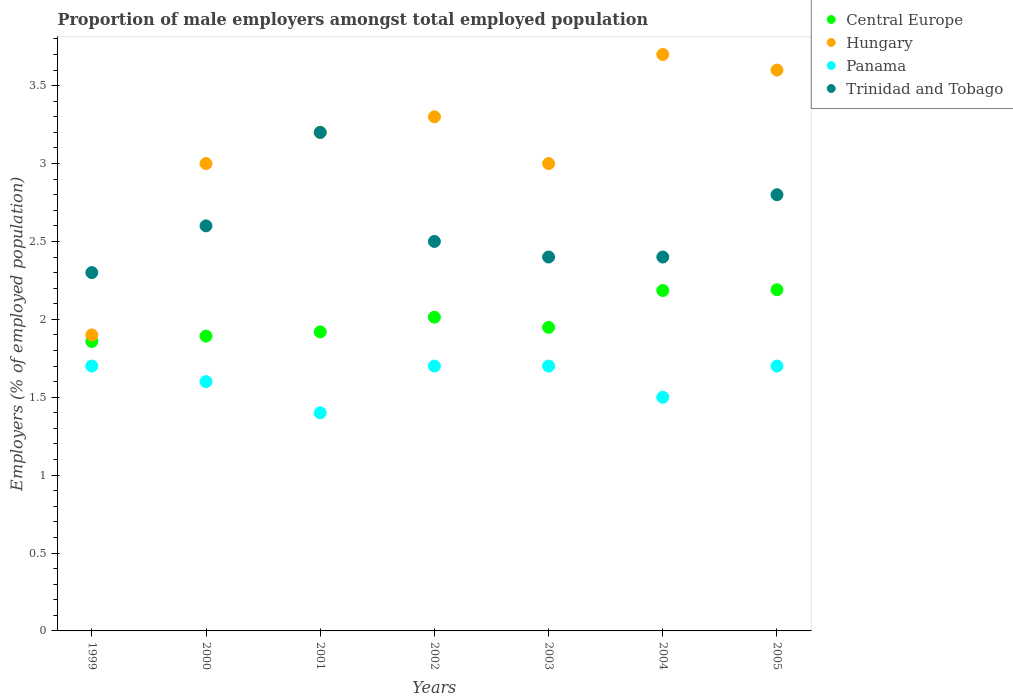Is the number of dotlines equal to the number of legend labels?
Keep it short and to the point. Yes. What is the proportion of male employers in Hungary in 2002?
Your answer should be compact. 3.3. Across all years, what is the maximum proportion of male employers in Hungary?
Offer a very short reply. 3.7. Across all years, what is the minimum proportion of male employers in Central Europe?
Provide a succinct answer. 1.86. In which year was the proportion of male employers in Hungary minimum?
Offer a terse response. 1999. What is the total proportion of male employers in Trinidad and Tobago in the graph?
Offer a terse response. 18.2. What is the difference between the proportion of male employers in Panama in 2001 and that in 2002?
Ensure brevity in your answer.  -0.3. What is the difference between the proportion of male employers in Panama in 2002 and the proportion of male employers in Hungary in 1999?
Provide a short and direct response. -0.2. What is the average proportion of male employers in Trinidad and Tobago per year?
Keep it short and to the point. 2.6. In the year 2005, what is the difference between the proportion of male employers in Central Europe and proportion of male employers in Panama?
Offer a very short reply. 0.49. In how many years, is the proportion of male employers in Hungary greater than 1.4 %?
Your answer should be compact. 7. Is the proportion of male employers in Hungary in 2002 less than that in 2003?
Your answer should be very brief. No. What is the difference between the highest and the second highest proportion of male employers in Hungary?
Provide a succinct answer. 0.1. What is the difference between the highest and the lowest proportion of male employers in Panama?
Provide a short and direct response. 0.3. Is the sum of the proportion of male employers in Hungary in 2000 and 2001 greater than the maximum proportion of male employers in Central Europe across all years?
Offer a terse response. Yes. Is it the case that in every year, the sum of the proportion of male employers in Central Europe and proportion of male employers in Hungary  is greater than the sum of proportion of male employers in Panama and proportion of male employers in Trinidad and Tobago?
Offer a very short reply. Yes. How many years are there in the graph?
Provide a succinct answer. 7. Does the graph contain grids?
Offer a very short reply. No. What is the title of the graph?
Offer a terse response. Proportion of male employers amongst total employed population. What is the label or title of the X-axis?
Your answer should be compact. Years. What is the label or title of the Y-axis?
Your response must be concise. Employers (% of employed population). What is the Employers (% of employed population) of Central Europe in 1999?
Your response must be concise. 1.86. What is the Employers (% of employed population) in Hungary in 1999?
Keep it short and to the point. 1.9. What is the Employers (% of employed population) of Panama in 1999?
Provide a short and direct response. 1.7. What is the Employers (% of employed population) of Trinidad and Tobago in 1999?
Give a very brief answer. 2.3. What is the Employers (% of employed population) in Central Europe in 2000?
Make the answer very short. 1.89. What is the Employers (% of employed population) in Panama in 2000?
Make the answer very short. 1.6. What is the Employers (% of employed population) in Trinidad and Tobago in 2000?
Provide a short and direct response. 2.6. What is the Employers (% of employed population) of Central Europe in 2001?
Ensure brevity in your answer.  1.92. What is the Employers (% of employed population) in Hungary in 2001?
Your answer should be compact. 3.2. What is the Employers (% of employed population) in Panama in 2001?
Your answer should be very brief. 1.4. What is the Employers (% of employed population) in Trinidad and Tobago in 2001?
Your answer should be compact. 3.2. What is the Employers (% of employed population) in Central Europe in 2002?
Offer a very short reply. 2.01. What is the Employers (% of employed population) in Hungary in 2002?
Give a very brief answer. 3.3. What is the Employers (% of employed population) of Panama in 2002?
Your response must be concise. 1.7. What is the Employers (% of employed population) of Trinidad and Tobago in 2002?
Give a very brief answer. 2.5. What is the Employers (% of employed population) in Central Europe in 2003?
Your response must be concise. 1.95. What is the Employers (% of employed population) in Hungary in 2003?
Your answer should be compact. 3. What is the Employers (% of employed population) of Panama in 2003?
Offer a terse response. 1.7. What is the Employers (% of employed population) of Trinidad and Tobago in 2003?
Offer a terse response. 2.4. What is the Employers (% of employed population) in Central Europe in 2004?
Make the answer very short. 2.19. What is the Employers (% of employed population) in Hungary in 2004?
Give a very brief answer. 3.7. What is the Employers (% of employed population) in Trinidad and Tobago in 2004?
Your answer should be compact. 2.4. What is the Employers (% of employed population) of Central Europe in 2005?
Your answer should be compact. 2.19. What is the Employers (% of employed population) of Hungary in 2005?
Keep it short and to the point. 3.6. What is the Employers (% of employed population) of Panama in 2005?
Provide a succinct answer. 1.7. What is the Employers (% of employed population) of Trinidad and Tobago in 2005?
Make the answer very short. 2.8. Across all years, what is the maximum Employers (% of employed population) of Central Europe?
Your answer should be compact. 2.19. Across all years, what is the maximum Employers (% of employed population) of Hungary?
Provide a short and direct response. 3.7. Across all years, what is the maximum Employers (% of employed population) of Panama?
Give a very brief answer. 1.7. Across all years, what is the maximum Employers (% of employed population) of Trinidad and Tobago?
Keep it short and to the point. 3.2. Across all years, what is the minimum Employers (% of employed population) of Central Europe?
Your answer should be compact. 1.86. Across all years, what is the minimum Employers (% of employed population) in Hungary?
Offer a terse response. 1.9. Across all years, what is the minimum Employers (% of employed population) in Panama?
Provide a succinct answer. 1.4. Across all years, what is the minimum Employers (% of employed population) of Trinidad and Tobago?
Offer a very short reply. 2.3. What is the total Employers (% of employed population) in Central Europe in the graph?
Make the answer very short. 14.01. What is the total Employers (% of employed population) of Hungary in the graph?
Offer a terse response. 21.7. What is the total Employers (% of employed population) of Panama in the graph?
Ensure brevity in your answer.  11.3. What is the total Employers (% of employed population) of Trinidad and Tobago in the graph?
Offer a terse response. 18.2. What is the difference between the Employers (% of employed population) in Central Europe in 1999 and that in 2000?
Your answer should be very brief. -0.03. What is the difference between the Employers (% of employed population) in Panama in 1999 and that in 2000?
Your response must be concise. 0.1. What is the difference between the Employers (% of employed population) in Central Europe in 1999 and that in 2001?
Provide a succinct answer. -0.06. What is the difference between the Employers (% of employed population) of Hungary in 1999 and that in 2001?
Offer a very short reply. -1.3. What is the difference between the Employers (% of employed population) in Panama in 1999 and that in 2001?
Make the answer very short. 0.3. What is the difference between the Employers (% of employed population) of Central Europe in 1999 and that in 2002?
Make the answer very short. -0.16. What is the difference between the Employers (% of employed population) in Hungary in 1999 and that in 2002?
Your answer should be very brief. -1.4. What is the difference between the Employers (% of employed population) of Trinidad and Tobago in 1999 and that in 2002?
Keep it short and to the point. -0.2. What is the difference between the Employers (% of employed population) in Central Europe in 1999 and that in 2003?
Offer a very short reply. -0.09. What is the difference between the Employers (% of employed population) in Panama in 1999 and that in 2003?
Ensure brevity in your answer.  0. What is the difference between the Employers (% of employed population) in Trinidad and Tobago in 1999 and that in 2003?
Your response must be concise. -0.1. What is the difference between the Employers (% of employed population) in Central Europe in 1999 and that in 2004?
Your answer should be very brief. -0.33. What is the difference between the Employers (% of employed population) of Hungary in 1999 and that in 2004?
Make the answer very short. -1.8. What is the difference between the Employers (% of employed population) in Panama in 1999 and that in 2004?
Keep it short and to the point. 0.2. What is the difference between the Employers (% of employed population) in Central Europe in 1999 and that in 2005?
Your answer should be compact. -0.33. What is the difference between the Employers (% of employed population) of Hungary in 1999 and that in 2005?
Your answer should be compact. -1.7. What is the difference between the Employers (% of employed population) in Panama in 1999 and that in 2005?
Make the answer very short. 0. What is the difference between the Employers (% of employed population) of Trinidad and Tobago in 1999 and that in 2005?
Make the answer very short. -0.5. What is the difference between the Employers (% of employed population) in Central Europe in 2000 and that in 2001?
Your response must be concise. -0.03. What is the difference between the Employers (% of employed population) in Trinidad and Tobago in 2000 and that in 2001?
Provide a succinct answer. -0.6. What is the difference between the Employers (% of employed population) of Central Europe in 2000 and that in 2002?
Your answer should be compact. -0.12. What is the difference between the Employers (% of employed population) in Hungary in 2000 and that in 2002?
Give a very brief answer. -0.3. What is the difference between the Employers (% of employed population) in Panama in 2000 and that in 2002?
Make the answer very short. -0.1. What is the difference between the Employers (% of employed population) in Central Europe in 2000 and that in 2003?
Provide a short and direct response. -0.06. What is the difference between the Employers (% of employed population) of Panama in 2000 and that in 2003?
Keep it short and to the point. -0.1. What is the difference between the Employers (% of employed population) in Central Europe in 2000 and that in 2004?
Provide a short and direct response. -0.29. What is the difference between the Employers (% of employed population) in Panama in 2000 and that in 2004?
Provide a succinct answer. 0.1. What is the difference between the Employers (% of employed population) in Central Europe in 2000 and that in 2005?
Your answer should be very brief. -0.3. What is the difference between the Employers (% of employed population) in Hungary in 2000 and that in 2005?
Offer a very short reply. -0.6. What is the difference between the Employers (% of employed population) in Central Europe in 2001 and that in 2002?
Offer a very short reply. -0.09. What is the difference between the Employers (% of employed population) in Hungary in 2001 and that in 2002?
Provide a short and direct response. -0.1. What is the difference between the Employers (% of employed population) of Panama in 2001 and that in 2002?
Keep it short and to the point. -0.3. What is the difference between the Employers (% of employed population) of Trinidad and Tobago in 2001 and that in 2002?
Your answer should be very brief. 0.7. What is the difference between the Employers (% of employed population) of Central Europe in 2001 and that in 2003?
Ensure brevity in your answer.  -0.03. What is the difference between the Employers (% of employed population) in Hungary in 2001 and that in 2003?
Offer a terse response. 0.2. What is the difference between the Employers (% of employed population) in Panama in 2001 and that in 2003?
Make the answer very short. -0.3. What is the difference between the Employers (% of employed population) of Trinidad and Tobago in 2001 and that in 2003?
Your answer should be compact. 0.8. What is the difference between the Employers (% of employed population) of Central Europe in 2001 and that in 2004?
Keep it short and to the point. -0.27. What is the difference between the Employers (% of employed population) in Hungary in 2001 and that in 2004?
Your response must be concise. -0.5. What is the difference between the Employers (% of employed population) of Trinidad and Tobago in 2001 and that in 2004?
Keep it short and to the point. 0.8. What is the difference between the Employers (% of employed population) in Central Europe in 2001 and that in 2005?
Give a very brief answer. -0.27. What is the difference between the Employers (% of employed population) in Panama in 2001 and that in 2005?
Ensure brevity in your answer.  -0.3. What is the difference between the Employers (% of employed population) of Central Europe in 2002 and that in 2003?
Provide a short and direct response. 0.07. What is the difference between the Employers (% of employed population) of Hungary in 2002 and that in 2003?
Your answer should be very brief. 0.3. What is the difference between the Employers (% of employed population) in Panama in 2002 and that in 2003?
Offer a very short reply. 0. What is the difference between the Employers (% of employed population) in Central Europe in 2002 and that in 2004?
Provide a succinct answer. -0.17. What is the difference between the Employers (% of employed population) in Hungary in 2002 and that in 2004?
Your response must be concise. -0.4. What is the difference between the Employers (% of employed population) of Central Europe in 2002 and that in 2005?
Provide a short and direct response. -0.18. What is the difference between the Employers (% of employed population) of Trinidad and Tobago in 2002 and that in 2005?
Your answer should be compact. -0.3. What is the difference between the Employers (% of employed population) in Central Europe in 2003 and that in 2004?
Make the answer very short. -0.24. What is the difference between the Employers (% of employed population) in Hungary in 2003 and that in 2004?
Offer a terse response. -0.7. What is the difference between the Employers (% of employed population) of Panama in 2003 and that in 2004?
Offer a very short reply. 0.2. What is the difference between the Employers (% of employed population) of Trinidad and Tobago in 2003 and that in 2004?
Your answer should be very brief. 0. What is the difference between the Employers (% of employed population) in Central Europe in 2003 and that in 2005?
Provide a succinct answer. -0.24. What is the difference between the Employers (% of employed population) of Hungary in 2003 and that in 2005?
Make the answer very short. -0.6. What is the difference between the Employers (% of employed population) of Central Europe in 2004 and that in 2005?
Offer a terse response. -0.01. What is the difference between the Employers (% of employed population) of Central Europe in 1999 and the Employers (% of employed population) of Hungary in 2000?
Keep it short and to the point. -1.14. What is the difference between the Employers (% of employed population) of Central Europe in 1999 and the Employers (% of employed population) of Panama in 2000?
Keep it short and to the point. 0.26. What is the difference between the Employers (% of employed population) in Central Europe in 1999 and the Employers (% of employed population) in Trinidad and Tobago in 2000?
Make the answer very short. -0.74. What is the difference between the Employers (% of employed population) in Central Europe in 1999 and the Employers (% of employed population) in Hungary in 2001?
Ensure brevity in your answer.  -1.34. What is the difference between the Employers (% of employed population) of Central Europe in 1999 and the Employers (% of employed population) of Panama in 2001?
Your response must be concise. 0.46. What is the difference between the Employers (% of employed population) in Central Europe in 1999 and the Employers (% of employed population) in Trinidad and Tobago in 2001?
Offer a very short reply. -1.34. What is the difference between the Employers (% of employed population) in Hungary in 1999 and the Employers (% of employed population) in Trinidad and Tobago in 2001?
Keep it short and to the point. -1.3. What is the difference between the Employers (% of employed population) in Central Europe in 1999 and the Employers (% of employed population) in Hungary in 2002?
Your answer should be compact. -1.44. What is the difference between the Employers (% of employed population) in Central Europe in 1999 and the Employers (% of employed population) in Panama in 2002?
Provide a short and direct response. 0.16. What is the difference between the Employers (% of employed population) in Central Europe in 1999 and the Employers (% of employed population) in Trinidad and Tobago in 2002?
Make the answer very short. -0.64. What is the difference between the Employers (% of employed population) of Hungary in 1999 and the Employers (% of employed population) of Panama in 2002?
Make the answer very short. 0.2. What is the difference between the Employers (% of employed population) of Hungary in 1999 and the Employers (% of employed population) of Trinidad and Tobago in 2002?
Offer a terse response. -0.6. What is the difference between the Employers (% of employed population) of Panama in 1999 and the Employers (% of employed population) of Trinidad and Tobago in 2002?
Your response must be concise. -0.8. What is the difference between the Employers (% of employed population) of Central Europe in 1999 and the Employers (% of employed population) of Hungary in 2003?
Your response must be concise. -1.14. What is the difference between the Employers (% of employed population) of Central Europe in 1999 and the Employers (% of employed population) of Panama in 2003?
Keep it short and to the point. 0.16. What is the difference between the Employers (% of employed population) in Central Europe in 1999 and the Employers (% of employed population) in Trinidad and Tobago in 2003?
Your response must be concise. -0.54. What is the difference between the Employers (% of employed population) in Hungary in 1999 and the Employers (% of employed population) in Panama in 2003?
Offer a terse response. 0.2. What is the difference between the Employers (% of employed population) in Hungary in 1999 and the Employers (% of employed population) in Trinidad and Tobago in 2003?
Provide a succinct answer. -0.5. What is the difference between the Employers (% of employed population) of Panama in 1999 and the Employers (% of employed population) of Trinidad and Tobago in 2003?
Keep it short and to the point. -0.7. What is the difference between the Employers (% of employed population) in Central Europe in 1999 and the Employers (% of employed population) in Hungary in 2004?
Keep it short and to the point. -1.84. What is the difference between the Employers (% of employed population) in Central Europe in 1999 and the Employers (% of employed population) in Panama in 2004?
Ensure brevity in your answer.  0.36. What is the difference between the Employers (% of employed population) of Central Europe in 1999 and the Employers (% of employed population) of Trinidad and Tobago in 2004?
Keep it short and to the point. -0.54. What is the difference between the Employers (% of employed population) in Central Europe in 1999 and the Employers (% of employed population) in Hungary in 2005?
Provide a succinct answer. -1.74. What is the difference between the Employers (% of employed population) of Central Europe in 1999 and the Employers (% of employed population) of Panama in 2005?
Ensure brevity in your answer.  0.16. What is the difference between the Employers (% of employed population) in Central Europe in 1999 and the Employers (% of employed population) in Trinidad and Tobago in 2005?
Offer a very short reply. -0.94. What is the difference between the Employers (% of employed population) in Hungary in 1999 and the Employers (% of employed population) in Panama in 2005?
Offer a very short reply. 0.2. What is the difference between the Employers (% of employed population) of Central Europe in 2000 and the Employers (% of employed population) of Hungary in 2001?
Offer a very short reply. -1.31. What is the difference between the Employers (% of employed population) in Central Europe in 2000 and the Employers (% of employed population) in Panama in 2001?
Provide a succinct answer. 0.49. What is the difference between the Employers (% of employed population) of Central Europe in 2000 and the Employers (% of employed population) of Trinidad and Tobago in 2001?
Ensure brevity in your answer.  -1.31. What is the difference between the Employers (% of employed population) in Hungary in 2000 and the Employers (% of employed population) in Trinidad and Tobago in 2001?
Give a very brief answer. -0.2. What is the difference between the Employers (% of employed population) of Central Europe in 2000 and the Employers (% of employed population) of Hungary in 2002?
Your response must be concise. -1.41. What is the difference between the Employers (% of employed population) in Central Europe in 2000 and the Employers (% of employed population) in Panama in 2002?
Provide a succinct answer. 0.19. What is the difference between the Employers (% of employed population) of Central Europe in 2000 and the Employers (% of employed population) of Trinidad and Tobago in 2002?
Your response must be concise. -0.61. What is the difference between the Employers (% of employed population) in Hungary in 2000 and the Employers (% of employed population) in Panama in 2002?
Offer a terse response. 1.3. What is the difference between the Employers (% of employed population) in Panama in 2000 and the Employers (% of employed population) in Trinidad and Tobago in 2002?
Your answer should be very brief. -0.9. What is the difference between the Employers (% of employed population) in Central Europe in 2000 and the Employers (% of employed population) in Hungary in 2003?
Your answer should be very brief. -1.11. What is the difference between the Employers (% of employed population) of Central Europe in 2000 and the Employers (% of employed population) of Panama in 2003?
Make the answer very short. 0.19. What is the difference between the Employers (% of employed population) in Central Europe in 2000 and the Employers (% of employed population) in Trinidad and Tobago in 2003?
Offer a very short reply. -0.51. What is the difference between the Employers (% of employed population) in Hungary in 2000 and the Employers (% of employed population) in Panama in 2003?
Ensure brevity in your answer.  1.3. What is the difference between the Employers (% of employed population) in Hungary in 2000 and the Employers (% of employed population) in Trinidad and Tobago in 2003?
Provide a succinct answer. 0.6. What is the difference between the Employers (% of employed population) in Central Europe in 2000 and the Employers (% of employed population) in Hungary in 2004?
Ensure brevity in your answer.  -1.81. What is the difference between the Employers (% of employed population) of Central Europe in 2000 and the Employers (% of employed population) of Panama in 2004?
Your answer should be very brief. 0.39. What is the difference between the Employers (% of employed population) of Central Europe in 2000 and the Employers (% of employed population) of Trinidad and Tobago in 2004?
Your answer should be very brief. -0.51. What is the difference between the Employers (% of employed population) in Hungary in 2000 and the Employers (% of employed population) in Panama in 2004?
Keep it short and to the point. 1.5. What is the difference between the Employers (% of employed population) in Hungary in 2000 and the Employers (% of employed population) in Trinidad and Tobago in 2004?
Give a very brief answer. 0.6. What is the difference between the Employers (% of employed population) in Central Europe in 2000 and the Employers (% of employed population) in Hungary in 2005?
Your answer should be very brief. -1.71. What is the difference between the Employers (% of employed population) of Central Europe in 2000 and the Employers (% of employed population) of Panama in 2005?
Offer a terse response. 0.19. What is the difference between the Employers (% of employed population) of Central Europe in 2000 and the Employers (% of employed population) of Trinidad and Tobago in 2005?
Make the answer very short. -0.91. What is the difference between the Employers (% of employed population) in Hungary in 2000 and the Employers (% of employed population) in Trinidad and Tobago in 2005?
Provide a short and direct response. 0.2. What is the difference between the Employers (% of employed population) in Central Europe in 2001 and the Employers (% of employed population) in Hungary in 2002?
Make the answer very short. -1.38. What is the difference between the Employers (% of employed population) of Central Europe in 2001 and the Employers (% of employed population) of Panama in 2002?
Offer a very short reply. 0.22. What is the difference between the Employers (% of employed population) of Central Europe in 2001 and the Employers (% of employed population) of Trinidad and Tobago in 2002?
Ensure brevity in your answer.  -0.58. What is the difference between the Employers (% of employed population) of Hungary in 2001 and the Employers (% of employed population) of Trinidad and Tobago in 2002?
Ensure brevity in your answer.  0.7. What is the difference between the Employers (% of employed population) in Panama in 2001 and the Employers (% of employed population) in Trinidad and Tobago in 2002?
Provide a short and direct response. -1.1. What is the difference between the Employers (% of employed population) of Central Europe in 2001 and the Employers (% of employed population) of Hungary in 2003?
Offer a very short reply. -1.08. What is the difference between the Employers (% of employed population) of Central Europe in 2001 and the Employers (% of employed population) of Panama in 2003?
Make the answer very short. 0.22. What is the difference between the Employers (% of employed population) of Central Europe in 2001 and the Employers (% of employed population) of Trinidad and Tobago in 2003?
Your response must be concise. -0.48. What is the difference between the Employers (% of employed population) of Central Europe in 2001 and the Employers (% of employed population) of Hungary in 2004?
Make the answer very short. -1.78. What is the difference between the Employers (% of employed population) of Central Europe in 2001 and the Employers (% of employed population) of Panama in 2004?
Keep it short and to the point. 0.42. What is the difference between the Employers (% of employed population) in Central Europe in 2001 and the Employers (% of employed population) in Trinidad and Tobago in 2004?
Keep it short and to the point. -0.48. What is the difference between the Employers (% of employed population) in Hungary in 2001 and the Employers (% of employed population) in Trinidad and Tobago in 2004?
Offer a terse response. 0.8. What is the difference between the Employers (% of employed population) in Central Europe in 2001 and the Employers (% of employed population) in Hungary in 2005?
Your response must be concise. -1.68. What is the difference between the Employers (% of employed population) in Central Europe in 2001 and the Employers (% of employed population) in Panama in 2005?
Your answer should be very brief. 0.22. What is the difference between the Employers (% of employed population) of Central Europe in 2001 and the Employers (% of employed population) of Trinidad and Tobago in 2005?
Your answer should be compact. -0.88. What is the difference between the Employers (% of employed population) of Hungary in 2001 and the Employers (% of employed population) of Panama in 2005?
Your answer should be very brief. 1.5. What is the difference between the Employers (% of employed population) of Panama in 2001 and the Employers (% of employed population) of Trinidad and Tobago in 2005?
Make the answer very short. -1.4. What is the difference between the Employers (% of employed population) in Central Europe in 2002 and the Employers (% of employed population) in Hungary in 2003?
Your answer should be compact. -0.99. What is the difference between the Employers (% of employed population) of Central Europe in 2002 and the Employers (% of employed population) of Panama in 2003?
Your answer should be compact. 0.31. What is the difference between the Employers (% of employed population) in Central Europe in 2002 and the Employers (% of employed population) in Trinidad and Tobago in 2003?
Make the answer very short. -0.39. What is the difference between the Employers (% of employed population) of Hungary in 2002 and the Employers (% of employed population) of Trinidad and Tobago in 2003?
Keep it short and to the point. 0.9. What is the difference between the Employers (% of employed population) in Panama in 2002 and the Employers (% of employed population) in Trinidad and Tobago in 2003?
Ensure brevity in your answer.  -0.7. What is the difference between the Employers (% of employed population) in Central Europe in 2002 and the Employers (% of employed population) in Hungary in 2004?
Ensure brevity in your answer.  -1.69. What is the difference between the Employers (% of employed population) in Central Europe in 2002 and the Employers (% of employed population) in Panama in 2004?
Your answer should be compact. 0.51. What is the difference between the Employers (% of employed population) of Central Europe in 2002 and the Employers (% of employed population) of Trinidad and Tobago in 2004?
Provide a succinct answer. -0.39. What is the difference between the Employers (% of employed population) of Hungary in 2002 and the Employers (% of employed population) of Panama in 2004?
Make the answer very short. 1.8. What is the difference between the Employers (% of employed population) of Central Europe in 2002 and the Employers (% of employed population) of Hungary in 2005?
Offer a terse response. -1.59. What is the difference between the Employers (% of employed population) in Central Europe in 2002 and the Employers (% of employed population) in Panama in 2005?
Your response must be concise. 0.31. What is the difference between the Employers (% of employed population) in Central Europe in 2002 and the Employers (% of employed population) in Trinidad and Tobago in 2005?
Provide a succinct answer. -0.79. What is the difference between the Employers (% of employed population) in Central Europe in 2003 and the Employers (% of employed population) in Hungary in 2004?
Offer a terse response. -1.75. What is the difference between the Employers (% of employed population) in Central Europe in 2003 and the Employers (% of employed population) in Panama in 2004?
Ensure brevity in your answer.  0.45. What is the difference between the Employers (% of employed population) in Central Europe in 2003 and the Employers (% of employed population) in Trinidad and Tobago in 2004?
Your response must be concise. -0.45. What is the difference between the Employers (% of employed population) of Hungary in 2003 and the Employers (% of employed population) of Trinidad and Tobago in 2004?
Your answer should be compact. 0.6. What is the difference between the Employers (% of employed population) of Central Europe in 2003 and the Employers (% of employed population) of Hungary in 2005?
Make the answer very short. -1.65. What is the difference between the Employers (% of employed population) of Central Europe in 2003 and the Employers (% of employed population) of Panama in 2005?
Make the answer very short. 0.25. What is the difference between the Employers (% of employed population) of Central Europe in 2003 and the Employers (% of employed population) of Trinidad and Tobago in 2005?
Provide a short and direct response. -0.85. What is the difference between the Employers (% of employed population) in Central Europe in 2004 and the Employers (% of employed population) in Hungary in 2005?
Provide a succinct answer. -1.42. What is the difference between the Employers (% of employed population) in Central Europe in 2004 and the Employers (% of employed population) in Panama in 2005?
Your response must be concise. 0.48. What is the difference between the Employers (% of employed population) in Central Europe in 2004 and the Employers (% of employed population) in Trinidad and Tobago in 2005?
Your answer should be very brief. -0.61. What is the difference between the Employers (% of employed population) in Hungary in 2004 and the Employers (% of employed population) in Panama in 2005?
Your answer should be very brief. 2. What is the difference between the Employers (% of employed population) of Panama in 2004 and the Employers (% of employed population) of Trinidad and Tobago in 2005?
Your response must be concise. -1.3. What is the average Employers (% of employed population) in Central Europe per year?
Provide a short and direct response. 2. What is the average Employers (% of employed population) in Hungary per year?
Ensure brevity in your answer.  3.1. What is the average Employers (% of employed population) of Panama per year?
Ensure brevity in your answer.  1.61. What is the average Employers (% of employed population) of Trinidad and Tobago per year?
Offer a very short reply. 2.6. In the year 1999, what is the difference between the Employers (% of employed population) of Central Europe and Employers (% of employed population) of Hungary?
Your response must be concise. -0.04. In the year 1999, what is the difference between the Employers (% of employed population) in Central Europe and Employers (% of employed population) in Panama?
Provide a succinct answer. 0.16. In the year 1999, what is the difference between the Employers (% of employed population) of Central Europe and Employers (% of employed population) of Trinidad and Tobago?
Your answer should be compact. -0.44. In the year 2000, what is the difference between the Employers (% of employed population) of Central Europe and Employers (% of employed population) of Hungary?
Offer a terse response. -1.11. In the year 2000, what is the difference between the Employers (% of employed population) of Central Europe and Employers (% of employed population) of Panama?
Provide a short and direct response. 0.29. In the year 2000, what is the difference between the Employers (% of employed population) in Central Europe and Employers (% of employed population) in Trinidad and Tobago?
Offer a terse response. -0.71. In the year 2000, what is the difference between the Employers (% of employed population) of Hungary and Employers (% of employed population) of Panama?
Offer a very short reply. 1.4. In the year 2000, what is the difference between the Employers (% of employed population) of Hungary and Employers (% of employed population) of Trinidad and Tobago?
Your answer should be very brief. 0.4. In the year 2000, what is the difference between the Employers (% of employed population) of Panama and Employers (% of employed population) of Trinidad and Tobago?
Give a very brief answer. -1. In the year 2001, what is the difference between the Employers (% of employed population) in Central Europe and Employers (% of employed population) in Hungary?
Ensure brevity in your answer.  -1.28. In the year 2001, what is the difference between the Employers (% of employed population) in Central Europe and Employers (% of employed population) in Panama?
Your answer should be very brief. 0.52. In the year 2001, what is the difference between the Employers (% of employed population) in Central Europe and Employers (% of employed population) in Trinidad and Tobago?
Provide a succinct answer. -1.28. In the year 2002, what is the difference between the Employers (% of employed population) in Central Europe and Employers (% of employed population) in Hungary?
Provide a short and direct response. -1.29. In the year 2002, what is the difference between the Employers (% of employed population) of Central Europe and Employers (% of employed population) of Panama?
Give a very brief answer. 0.31. In the year 2002, what is the difference between the Employers (% of employed population) in Central Europe and Employers (% of employed population) in Trinidad and Tobago?
Keep it short and to the point. -0.49. In the year 2003, what is the difference between the Employers (% of employed population) in Central Europe and Employers (% of employed population) in Hungary?
Your response must be concise. -1.05. In the year 2003, what is the difference between the Employers (% of employed population) of Central Europe and Employers (% of employed population) of Panama?
Your answer should be compact. 0.25. In the year 2003, what is the difference between the Employers (% of employed population) of Central Europe and Employers (% of employed population) of Trinidad and Tobago?
Your answer should be very brief. -0.45. In the year 2003, what is the difference between the Employers (% of employed population) in Hungary and Employers (% of employed population) in Panama?
Offer a terse response. 1.3. In the year 2004, what is the difference between the Employers (% of employed population) of Central Europe and Employers (% of employed population) of Hungary?
Offer a very short reply. -1.51. In the year 2004, what is the difference between the Employers (% of employed population) of Central Europe and Employers (% of employed population) of Panama?
Your answer should be very brief. 0.69. In the year 2004, what is the difference between the Employers (% of employed population) of Central Europe and Employers (% of employed population) of Trinidad and Tobago?
Provide a succinct answer. -0.21. In the year 2004, what is the difference between the Employers (% of employed population) of Panama and Employers (% of employed population) of Trinidad and Tobago?
Your answer should be very brief. -0.9. In the year 2005, what is the difference between the Employers (% of employed population) in Central Europe and Employers (% of employed population) in Hungary?
Offer a very short reply. -1.41. In the year 2005, what is the difference between the Employers (% of employed population) of Central Europe and Employers (% of employed population) of Panama?
Offer a terse response. 0.49. In the year 2005, what is the difference between the Employers (% of employed population) of Central Europe and Employers (% of employed population) of Trinidad and Tobago?
Ensure brevity in your answer.  -0.61. In the year 2005, what is the difference between the Employers (% of employed population) in Hungary and Employers (% of employed population) in Panama?
Provide a short and direct response. 1.9. What is the ratio of the Employers (% of employed population) in Central Europe in 1999 to that in 2000?
Your response must be concise. 0.98. What is the ratio of the Employers (% of employed population) in Hungary in 1999 to that in 2000?
Ensure brevity in your answer.  0.63. What is the ratio of the Employers (% of employed population) of Panama in 1999 to that in 2000?
Make the answer very short. 1.06. What is the ratio of the Employers (% of employed population) in Trinidad and Tobago in 1999 to that in 2000?
Give a very brief answer. 0.88. What is the ratio of the Employers (% of employed population) of Hungary in 1999 to that in 2001?
Give a very brief answer. 0.59. What is the ratio of the Employers (% of employed population) in Panama in 1999 to that in 2001?
Offer a terse response. 1.21. What is the ratio of the Employers (% of employed population) of Trinidad and Tobago in 1999 to that in 2001?
Your answer should be very brief. 0.72. What is the ratio of the Employers (% of employed population) of Central Europe in 1999 to that in 2002?
Ensure brevity in your answer.  0.92. What is the ratio of the Employers (% of employed population) in Hungary in 1999 to that in 2002?
Offer a very short reply. 0.58. What is the ratio of the Employers (% of employed population) of Trinidad and Tobago in 1999 to that in 2002?
Offer a very short reply. 0.92. What is the ratio of the Employers (% of employed population) in Central Europe in 1999 to that in 2003?
Offer a very short reply. 0.95. What is the ratio of the Employers (% of employed population) of Hungary in 1999 to that in 2003?
Keep it short and to the point. 0.63. What is the ratio of the Employers (% of employed population) in Panama in 1999 to that in 2003?
Offer a very short reply. 1. What is the ratio of the Employers (% of employed population) in Central Europe in 1999 to that in 2004?
Your response must be concise. 0.85. What is the ratio of the Employers (% of employed population) in Hungary in 1999 to that in 2004?
Give a very brief answer. 0.51. What is the ratio of the Employers (% of employed population) of Panama in 1999 to that in 2004?
Your response must be concise. 1.13. What is the ratio of the Employers (% of employed population) in Central Europe in 1999 to that in 2005?
Offer a terse response. 0.85. What is the ratio of the Employers (% of employed population) in Hungary in 1999 to that in 2005?
Offer a terse response. 0.53. What is the ratio of the Employers (% of employed population) in Trinidad and Tobago in 1999 to that in 2005?
Provide a short and direct response. 0.82. What is the ratio of the Employers (% of employed population) of Central Europe in 2000 to that in 2001?
Your response must be concise. 0.99. What is the ratio of the Employers (% of employed population) in Trinidad and Tobago in 2000 to that in 2001?
Provide a short and direct response. 0.81. What is the ratio of the Employers (% of employed population) in Central Europe in 2000 to that in 2002?
Ensure brevity in your answer.  0.94. What is the ratio of the Employers (% of employed population) of Hungary in 2000 to that in 2002?
Make the answer very short. 0.91. What is the ratio of the Employers (% of employed population) of Trinidad and Tobago in 2000 to that in 2002?
Your response must be concise. 1.04. What is the ratio of the Employers (% of employed population) of Central Europe in 2000 to that in 2003?
Make the answer very short. 0.97. What is the ratio of the Employers (% of employed population) in Hungary in 2000 to that in 2003?
Provide a succinct answer. 1. What is the ratio of the Employers (% of employed population) in Panama in 2000 to that in 2003?
Provide a succinct answer. 0.94. What is the ratio of the Employers (% of employed population) in Trinidad and Tobago in 2000 to that in 2003?
Keep it short and to the point. 1.08. What is the ratio of the Employers (% of employed population) of Central Europe in 2000 to that in 2004?
Provide a short and direct response. 0.87. What is the ratio of the Employers (% of employed population) of Hungary in 2000 to that in 2004?
Make the answer very short. 0.81. What is the ratio of the Employers (% of employed population) of Panama in 2000 to that in 2004?
Your answer should be very brief. 1.07. What is the ratio of the Employers (% of employed population) of Central Europe in 2000 to that in 2005?
Offer a terse response. 0.86. What is the ratio of the Employers (% of employed population) of Central Europe in 2001 to that in 2002?
Make the answer very short. 0.95. What is the ratio of the Employers (% of employed population) of Hungary in 2001 to that in 2002?
Keep it short and to the point. 0.97. What is the ratio of the Employers (% of employed population) of Panama in 2001 to that in 2002?
Offer a very short reply. 0.82. What is the ratio of the Employers (% of employed population) in Trinidad and Tobago in 2001 to that in 2002?
Your response must be concise. 1.28. What is the ratio of the Employers (% of employed population) of Central Europe in 2001 to that in 2003?
Your response must be concise. 0.99. What is the ratio of the Employers (% of employed population) in Hungary in 2001 to that in 2003?
Ensure brevity in your answer.  1.07. What is the ratio of the Employers (% of employed population) in Panama in 2001 to that in 2003?
Provide a succinct answer. 0.82. What is the ratio of the Employers (% of employed population) in Trinidad and Tobago in 2001 to that in 2003?
Provide a succinct answer. 1.33. What is the ratio of the Employers (% of employed population) in Central Europe in 2001 to that in 2004?
Give a very brief answer. 0.88. What is the ratio of the Employers (% of employed population) in Hungary in 2001 to that in 2004?
Offer a terse response. 0.86. What is the ratio of the Employers (% of employed population) in Panama in 2001 to that in 2004?
Keep it short and to the point. 0.93. What is the ratio of the Employers (% of employed population) of Central Europe in 2001 to that in 2005?
Offer a terse response. 0.88. What is the ratio of the Employers (% of employed population) in Panama in 2001 to that in 2005?
Keep it short and to the point. 0.82. What is the ratio of the Employers (% of employed population) in Central Europe in 2002 to that in 2003?
Provide a short and direct response. 1.03. What is the ratio of the Employers (% of employed population) of Hungary in 2002 to that in 2003?
Provide a short and direct response. 1.1. What is the ratio of the Employers (% of employed population) of Trinidad and Tobago in 2002 to that in 2003?
Give a very brief answer. 1.04. What is the ratio of the Employers (% of employed population) in Central Europe in 2002 to that in 2004?
Your response must be concise. 0.92. What is the ratio of the Employers (% of employed population) of Hungary in 2002 to that in 2004?
Your response must be concise. 0.89. What is the ratio of the Employers (% of employed population) of Panama in 2002 to that in 2004?
Keep it short and to the point. 1.13. What is the ratio of the Employers (% of employed population) in Trinidad and Tobago in 2002 to that in 2004?
Offer a terse response. 1.04. What is the ratio of the Employers (% of employed population) of Central Europe in 2002 to that in 2005?
Offer a very short reply. 0.92. What is the ratio of the Employers (% of employed population) in Hungary in 2002 to that in 2005?
Your response must be concise. 0.92. What is the ratio of the Employers (% of employed population) in Trinidad and Tobago in 2002 to that in 2005?
Your answer should be compact. 0.89. What is the ratio of the Employers (% of employed population) of Central Europe in 2003 to that in 2004?
Provide a short and direct response. 0.89. What is the ratio of the Employers (% of employed population) in Hungary in 2003 to that in 2004?
Make the answer very short. 0.81. What is the ratio of the Employers (% of employed population) of Panama in 2003 to that in 2004?
Give a very brief answer. 1.13. What is the ratio of the Employers (% of employed population) in Trinidad and Tobago in 2003 to that in 2004?
Give a very brief answer. 1. What is the ratio of the Employers (% of employed population) of Central Europe in 2003 to that in 2005?
Your response must be concise. 0.89. What is the ratio of the Employers (% of employed population) in Hungary in 2003 to that in 2005?
Ensure brevity in your answer.  0.83. What is the ratio of the Employers (% of employed population) in Panama in 2003 to that in 2005?
Your answer should be very brief. 1. What is the ratio of the Employers (% of employed population) in Trinidad and Tobago in 2003 to that in 2005?
Give a very brief answer. 0.86. What is the ratio of the Employers (% of employed population) in Central Europe in 2004 to that in 2005?
Provide a short and direct response. 1. What is the ratio of the Employers (% of employed population) in Hungary in 2004 to that in 2005?
Provide a short and direct response. 1.03. What is the ratio of the Employers (% of employed population) in Panama in 2004 to that in 2005?
Offer a terse response. 0.88. What is the ratio of the Employers (% of employed population) in Trinidad and Tobago in 2004 to that in 2005?
Ensure brevity in your answer.  0.86. What is the difference between the highest and the second highest Employers (% of employed population) of Central Europe?
Give a very brief answer. 0.01. What is the difference between the highest and the second highest Employers (% of employed population) of Hungary?
Offer a very short reply. 0.1. What is the difference between the highest and the lowest Employers (% of employed population) in Central Europe?
Your answer should be compact. 0.33. 